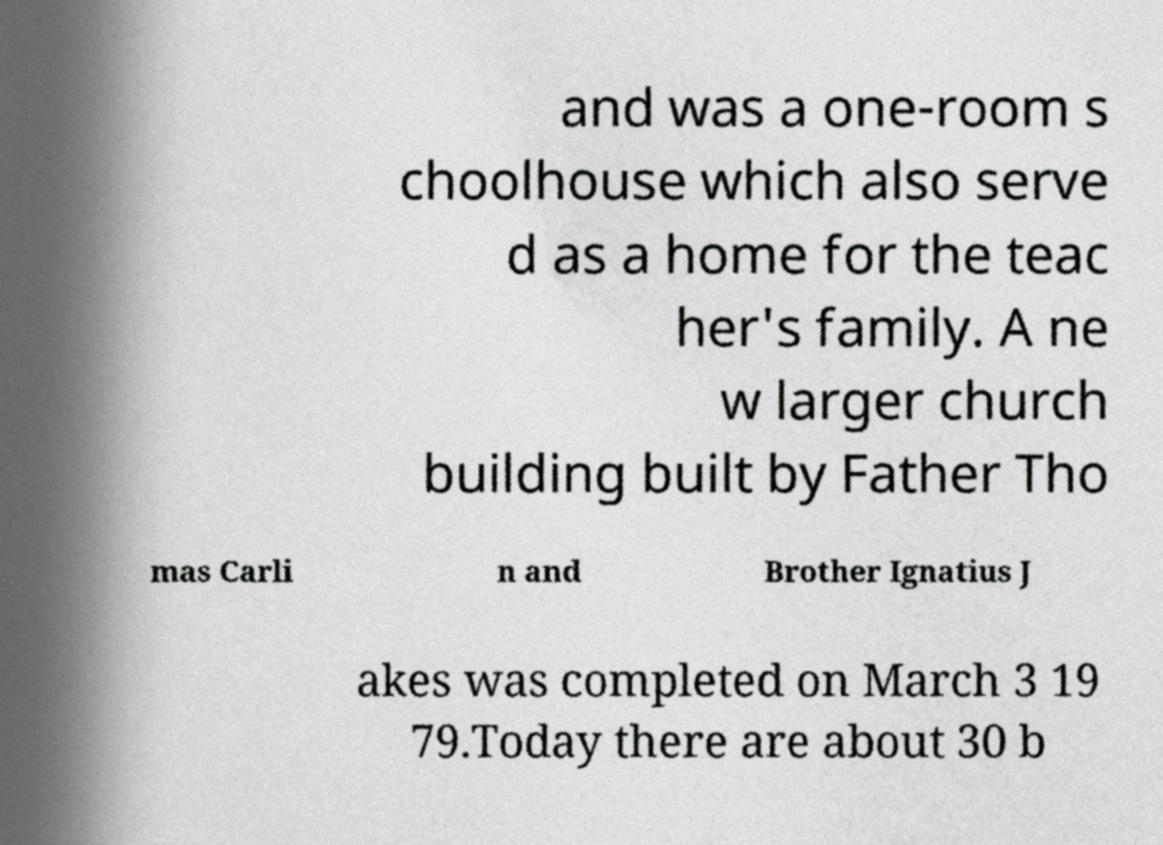I need the written content from this picture converted into text. Can you do that? and was a one-room s choolhouse which also serve d as a home for the teac her's family. A ne w larger church building built by Father Tho mas Carli n and Brother Ignatius J akes was completed on March 3 19 79.Today there are about 30 b 